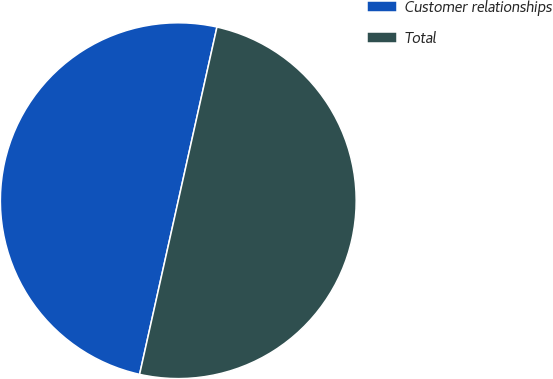<chart> <loc_0><loc_0><loc_500><loc_500><pie_chart><fcel>Customer relationships<fcel>Total<nl><fcel>50.0%<fcel>50.0%<nl></chart> 